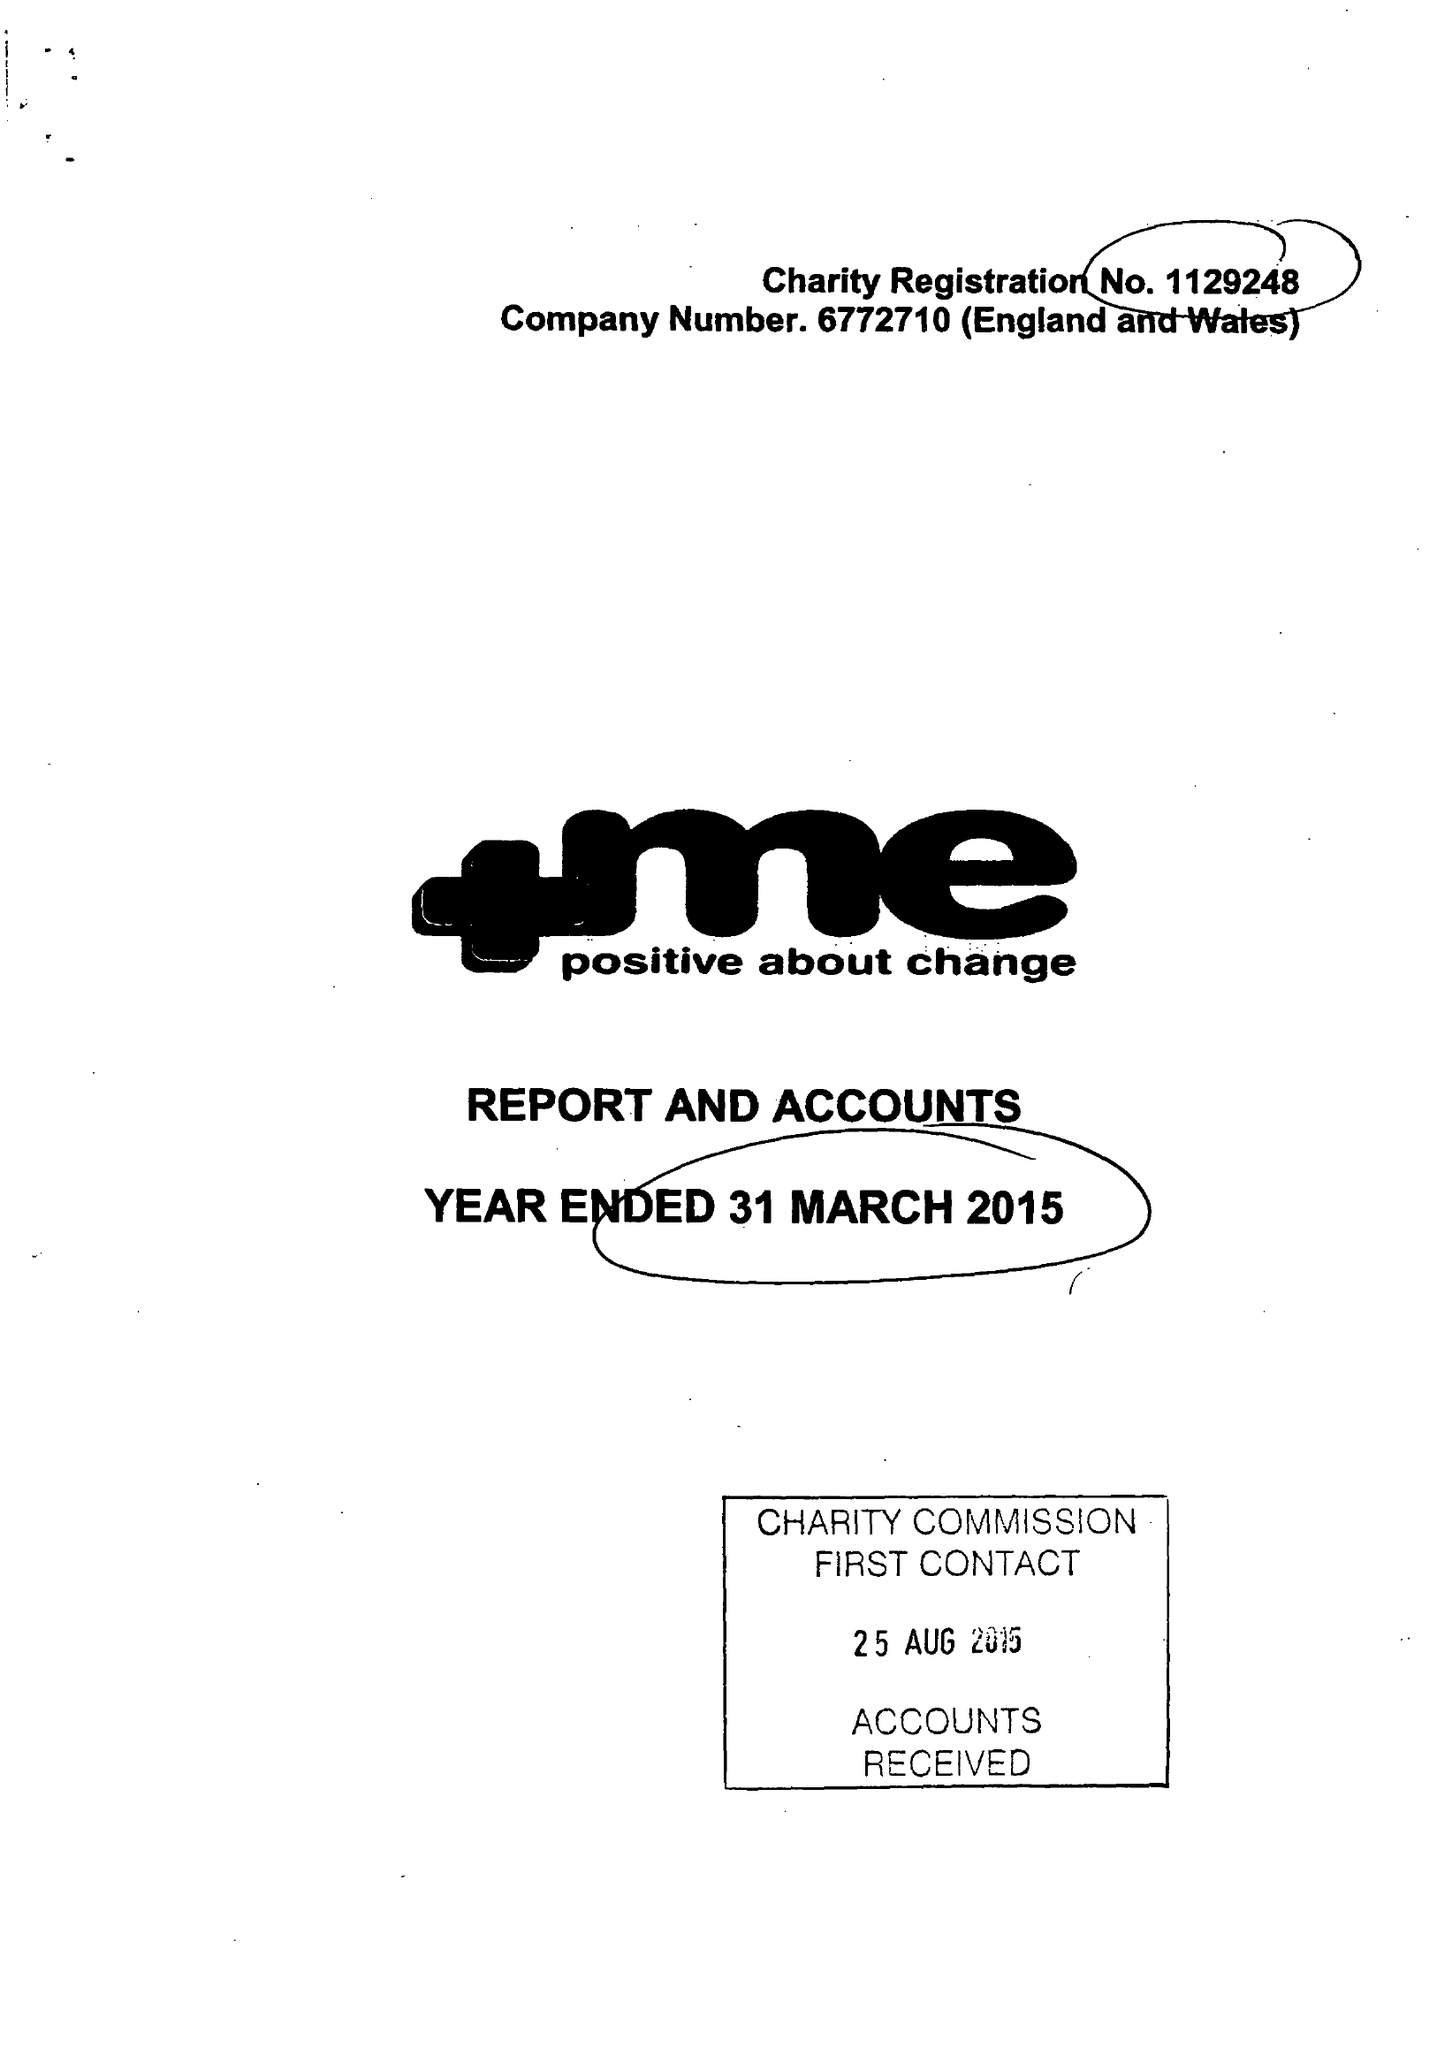What is the value for the charity_name?
Answer the question using a single word or phrase. +Me Positive About Change 